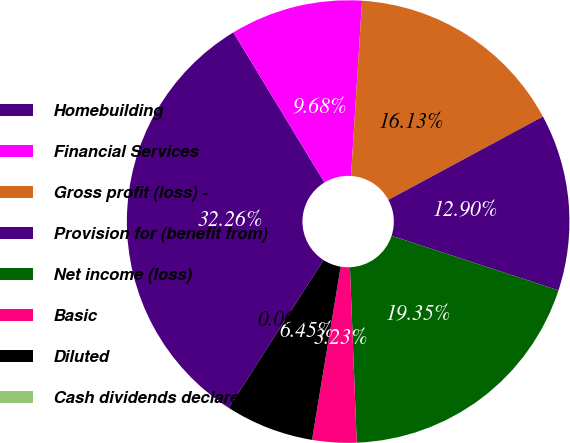Convert chart to OTSL. <chart><loc_0><loc_0><loc_500><loc_500><pie_chart><fcel>Homebuilding<fcel>Financial Services<fcel>Gross profit (loss) -<fcel>Provision for (benefit from)<fcel>Net income (loss)<fcel>Basic<fcel>Diluted<fcel>Cash dividends declared per<nl><fcel>32.26%<fcel>9.68%<fcel>16.13%<fcel>12.9%<fcel>19.35%<fcel>3.23%<fcel>6.45%<fcel>0.0%<nl></chart> 